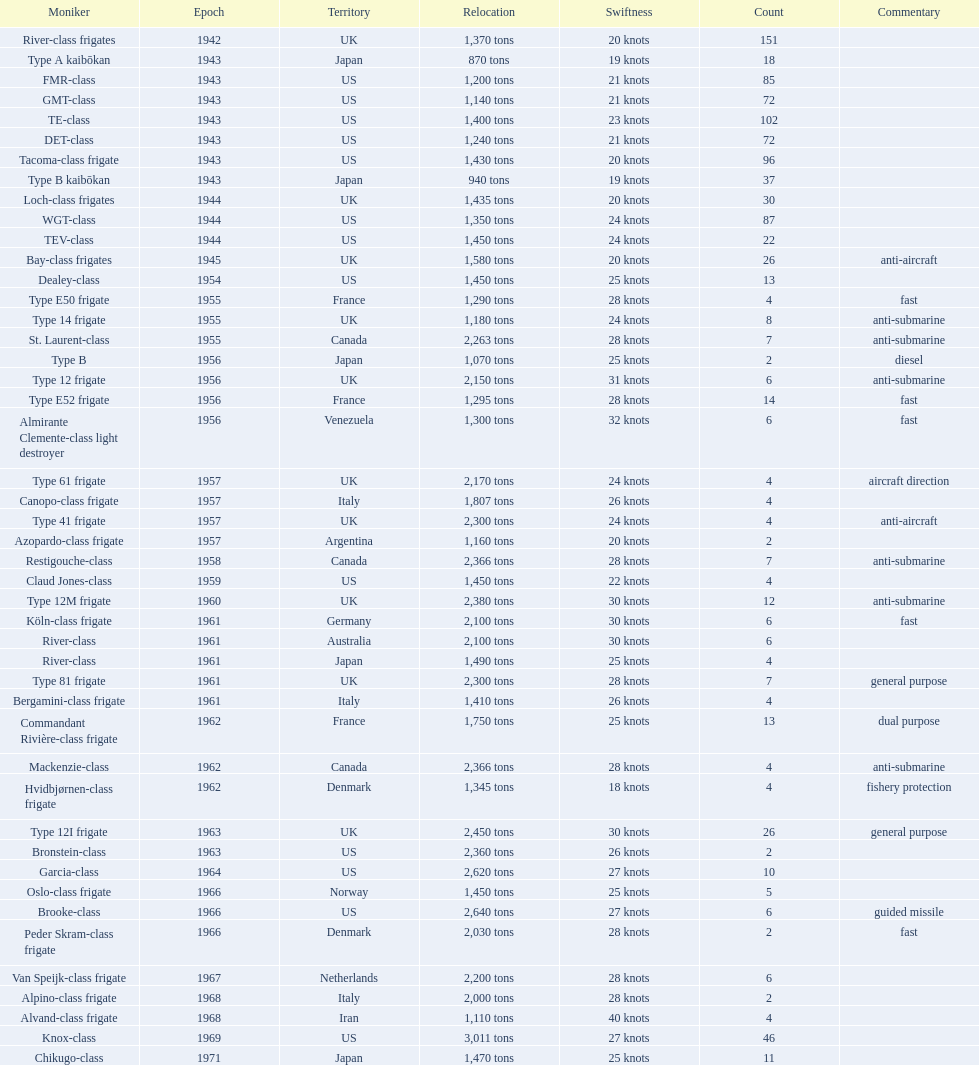Would you be able to parse every entry in this table? {'header': ['Moniker', 'Epoch', 'Territory', 'Relocation', 'Swiftness', 'Count', 'Commentary'], 'rows': [['River-class frigates', '1942', 'UK', '1,370 tons', '20 knots', '151', ''], ['Type A kaibōkan', '1943', 'Japan', '870 tons', '19 knots', '18', ''], ['FMR-class', '1943', 'US', '1,200 tons', '21 knots', '85', ''], ['GMT-class', '1943', 'US', '1,140 tons', '21 knots', '72', ''], ['TE-class', '1943', 'US', '1,400 tons', '23 knots', '102', ''], ['DET-class', '1943', 'US', '1,240 tons', '21 knots', '72', ''], ['Tacoma-class frigate', '1943', 'US', '1,430 tons', '20 knots', '96', ''], ['Type B kaibōkan', '1943', 'Japan', '940 tons', '19 knots', '37', ''], ['Loch-class frigates', '1944', 'UK', '1,435 tons', '20 knots', '30', ''], ['WGT-class', '1944', 'US', '1,350 tons', '24 knots', '87', ''], ['TEV-class', '1944', 'US', '1,450 tons', '24 knots', '22', ''], ['Bay-class frigates', '1945', 'UK', '1,580 tons', '20 knots', '26', 'anti-aircraft'], ['Dealey-class', '1954', 'US', '1,450 tons', '25 knots', '13', ''], ['Type E50 frigate', '1955', 'France', '1,290 tons', '28 knots', '4', 'fast'], ['Type 14 frigate', '1955', 'UK', '1,180 tons', '24 knots', '8', 'anti-submarine'], ['St. Laurent-class', '1955', 'Canada', '2,263 tons', '28 knots', '7', 'anti-submarine'], ['Type B', '1956', 'Japan', '1,070 tons', '25 knots', '2', 'diesel'], ['Type 12 frigate', '1956', 'UK', '2,150 tons', '31 knots', '6', 'anti-submarine'], ['Type E52 frigate', '1956', 'France', '1,295 tons', '28 knots', '14', 'fast'], ['Almirante Clemente-class light destroyer', '1956', 'Venezuela', '1,300 tons', '32 knots', '6', 'fast'], ['Type 61 frigate', '1957', 'UK', '2,170 tons', '24 knots', '4', 'aircraft direction'], ['Canopo-class frigate', '1957', 'Italy', '1,807 tons', '26 knots', '4', ''], ['Type 41 frigate', '1957', 'UK', '2,300 tons', '24 knots', '4', 'anti-aircraft'], ['Azopardo-class frigate', '1957', 'Argentina', '1,160 tons', '20 knots', '2', ''], ['Restigouche-class', '1958', 'Canada', '2,366 tons', '28 knots', '7', 'anti-submarine'], ['Claud Jones-class', '1959', 'US', '1,450 tons', '22 knots', '4', ''], ['Type 12M frigate', '1960', 'UK', '2,380 tons', '30 knots', '12', 'anti-submarine'], ['Köln-class frigate', '1961', 'Germany', '2,100 tons', '30 knots', '6', 'fast'], ['River-class', '1961', 'Australia', '2,100 tons', '30 knots', '6', ''], ['River-class', '1961', 'Japan', '1,490 tons', '25 knots', '4', ''], ['Type 81 frigate', '1961', 'UK', '2,300 tons', '28 knots', '7', 'general purpose'], ['Bergamini-class frigate', '1961', 'Italy', '1,410 tons', '26 knots', '4', ''], ['Commandant Rivière-class frigate', '1962', 'France', '1,750 tons', '25 knots', '13', 'dual purpose'], ['Mackenzie-class', '1962', 'Canada', '2,366 tons', '28 knots', '4', 'anti-submarine'], ['Hvidbjørnen-class frigate', '1962', 'Denmark', '1,345 tons', '18 knots', '4', 'fishery protection'], ['Type 12I frigate', '1963', 'UK', '2,450 tons', '30 knots', '26', 'general purpose'], ['Bronstein-class', '1963', 'US', '2,360 tons', '26 knots', '2', ''], ['Garcia-class', '1964', 'US', '2,620 tons', '27 knots', '10', ''], ['Oslo-class frigate', '1966', 'Norway', '1,450 tons', '25 knots', '5', ''], ['Brooke-class', '1966', 'US', '2,640 tons', '27 knots', '6', 'guided missile'], ['Peder Skram-class frigate', '1966', 'Denmark', '2,030 tons', '28 knots', '2', 'fast'], ['Van Speijk-class frigate', '1967', 'Netherlands', '2,200 tons', '28 knots', '6', ''], ['Alpino-class frigate', '1968', 'Italy', '2,000 tons', '28 knots', '2', ''], ['Alvand-class frigate', '1968', 'Iran', '1,110 tons', '40 knots', '4', ''], ['Knox-class', '1969', 'US', '3,011 tons', '27 knots', '46', ''], ['Chikugo-class', '1971', 'Japan', '1,470 tons', '25 knots', '11', '']]} In 1968 italy used alpino-class frigate. what was its top speed? 28 knots. 